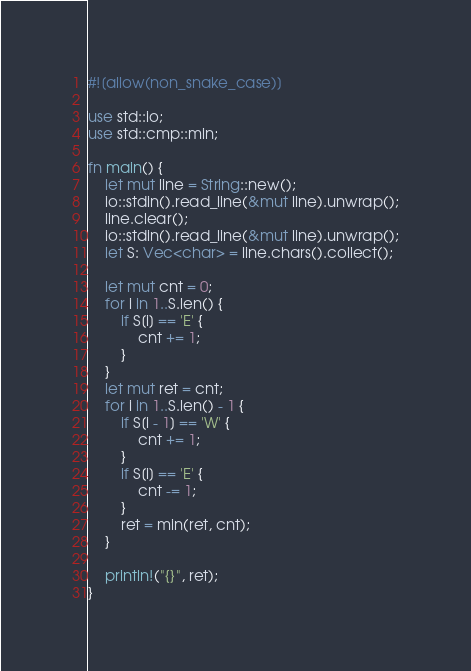Convert code to text. <code><loc_0><loc_0><loc_500><loc_500><_Rust_>#![allow(non_snake_case)]

use std::io;
use std::cmp::min;

fn main() {
    let mut line = String::new();
    io::stdin().read_line(&mut line).unwrap();
    line.clear();
    io::stdin().read_line(&mut line).unwrap();
    let S: Vec<char> = line.chars().collect();

    let mut cnt = 0;
    for i in 1..S.len() {
        if S[i] == 'E' {
            cnt += 1;
        }
    }
    let mut ret = cnt;
    for i in 1..S.len() - 1 {
        if S[i - 1] == 'W' {
            cnt += 1;
        }
        if S[i] == 'E' {
            cnt -= 1;
        }
        ret = min(ret, cnt);
    }

    println!("{}", ret);
}</code> 